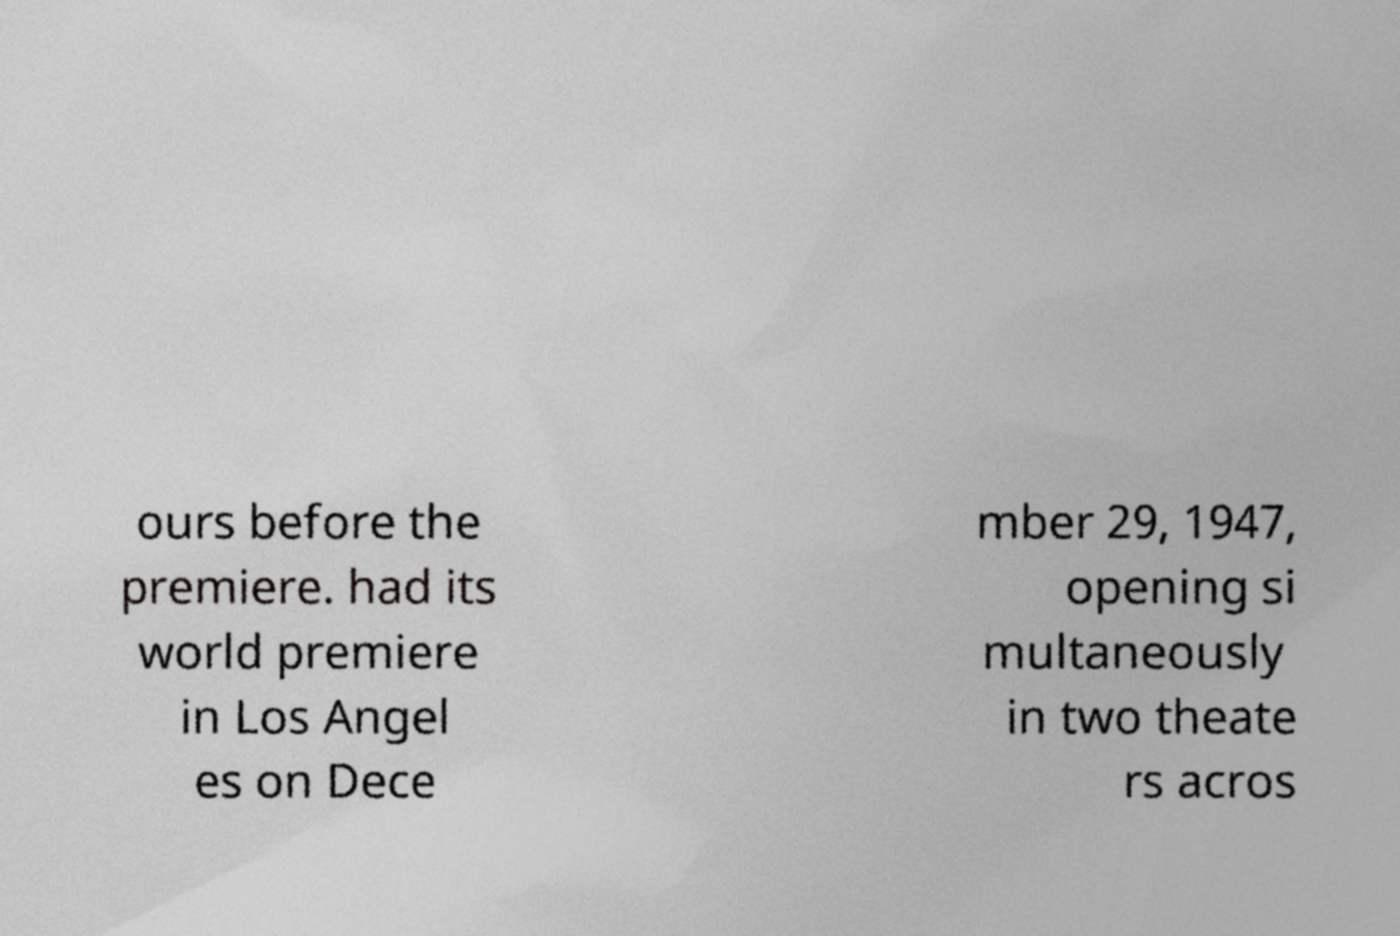I need the written content from this picture converted into text. Can you do that? ours before the premiere. had its world premiere in Los Angel es on Dece mber 29, 1947, opening si multaneously in two theate rs acros 